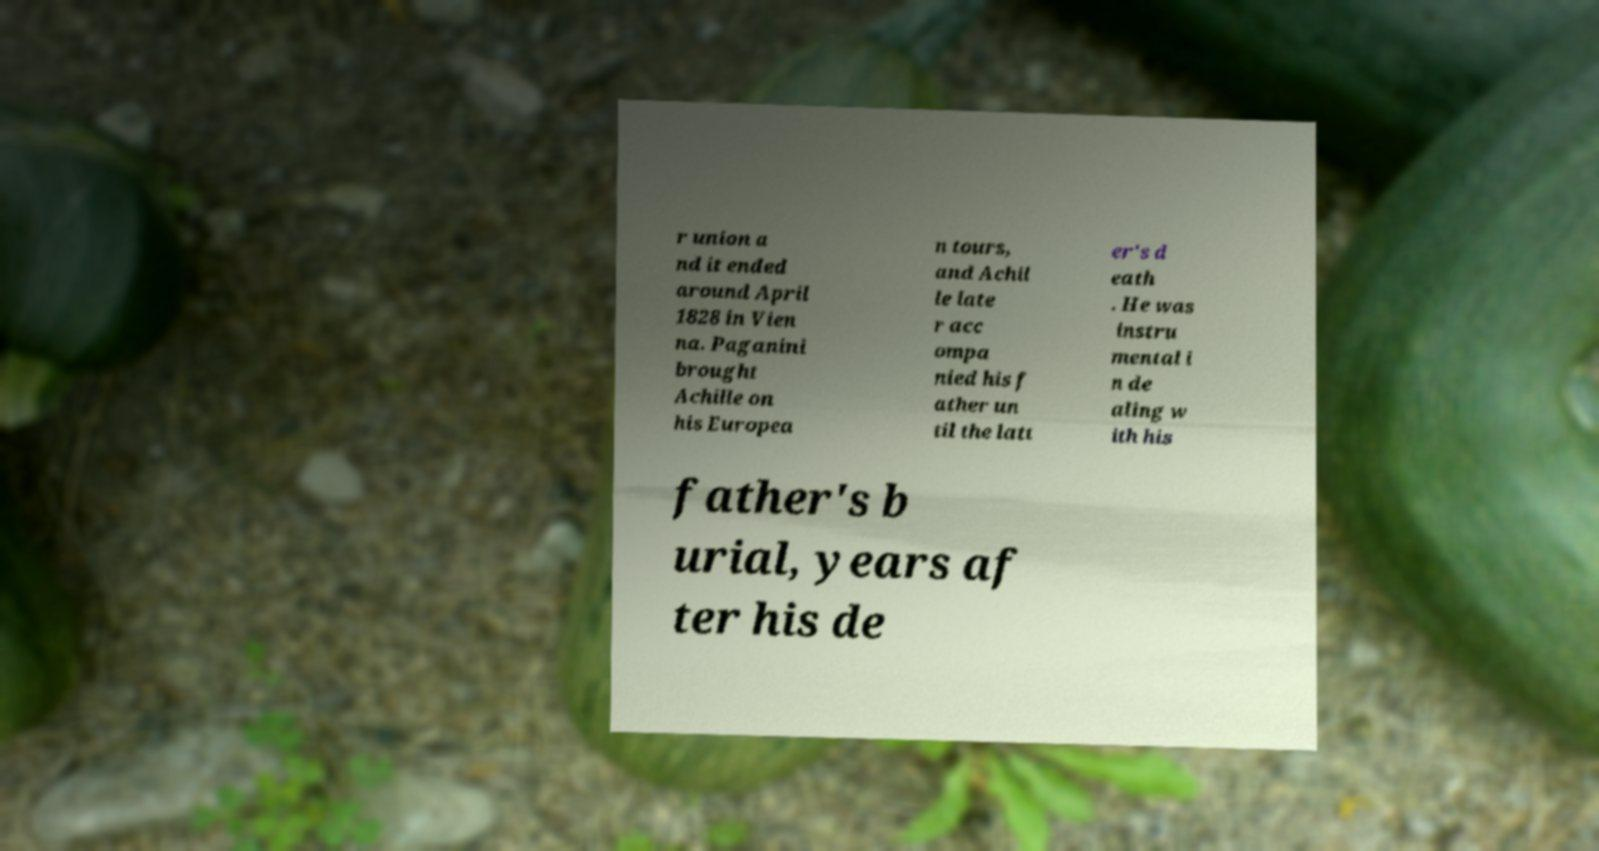For documentation purposes, I need the text within this image transcribed. Could you provide that? r union a nd it ended around April 1828 in Vien na. Paganini brought Achille on his Europea n tours, and Achil le late r acc ompa nied his f ather un til the latt er's d eath . He was instru mental i n de aling w ith his father's b urial, years af ter his de 